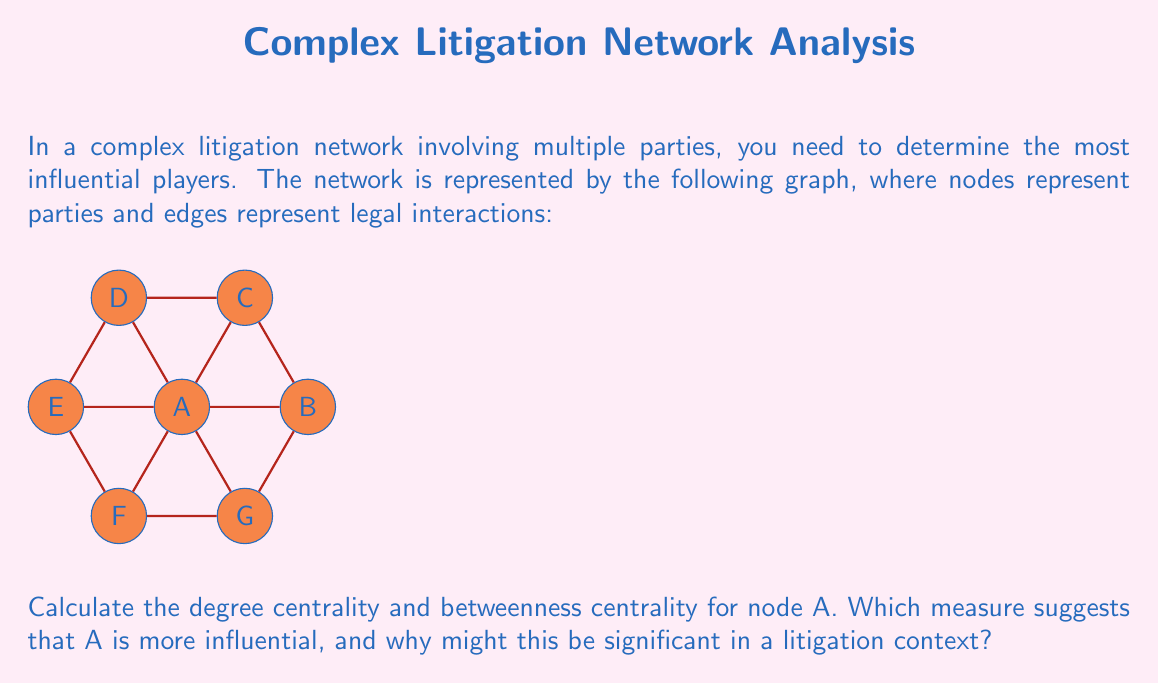Solve this math problem. To solve this problem, we need to calculate both the degree centrality and betweenness centrality for node A.

1. Degree Centrality:
   The degree centrality is simply the number of direct connections a node has.
   For node A, we can count 6 direct connections.
   Normalized degree centrality: $C_D(A) = \frac{6}{6} = 1$ (since there are 6 other nodes)

2. Betweenness Centrality:
   Betweenness centrality measures how often a node lies on the shortest path between other nodes.
   
   Step 1: Identify all shortest paths between pairs of nodes.
   Step 2: Count how many of these paths pass through node A.
   Step 3: Calculate the betweenness centrality.

   For this graph:
   - A is on the shortest path between B and D, B and E, C and F, C and G, D and G, E and G.
   - There are $\binom{6}{2} = 15$ possible pairs of nodes (excluding A).
   - A is on the shortest path for 6 of these pairs.

   Betweenness centrality: $C_B(A) = \frac{6}{15} = 0.4$

3. Comparison:
   Degree centrality: 1.0
   Betweenness centrality: 0.4

   The degree centrality suggests that A is more influential.

In a litigation context, this is significant because:
1. High degree centrality (1.0) indicates that A is directly involved with all other parties, suggesting it's a key player in the litigation network.
2. The lower betweenness centrality (0.4) suggests that while A is well-connected, it may not always be the intermediary between other parties.
3. As a lawyer, this implies that party A is likely a central figure in the case, perhaps the main plaintiff or defendant, but may not necessarily control all information flow or negotiations between other parties.
Answer: Degree centrality (1.0) suggests A is more influential; indicates direct involvement with all parties but not full control of inter-party communications. 